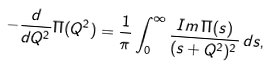<formula> <loc_0><loc_0><loc_500><loc_500>- \frac { d } { d Q ^ { 2 } } \Pi ( Q ^ { 2 } ) = \frac { 1 } { \pi } \int _ { 0 } ^ { \infty } \frac { I m \, \Pi ( s ) } { ( s + Q ^ { 2 } ) ^ { 2 } } \, d s ,</formula> 